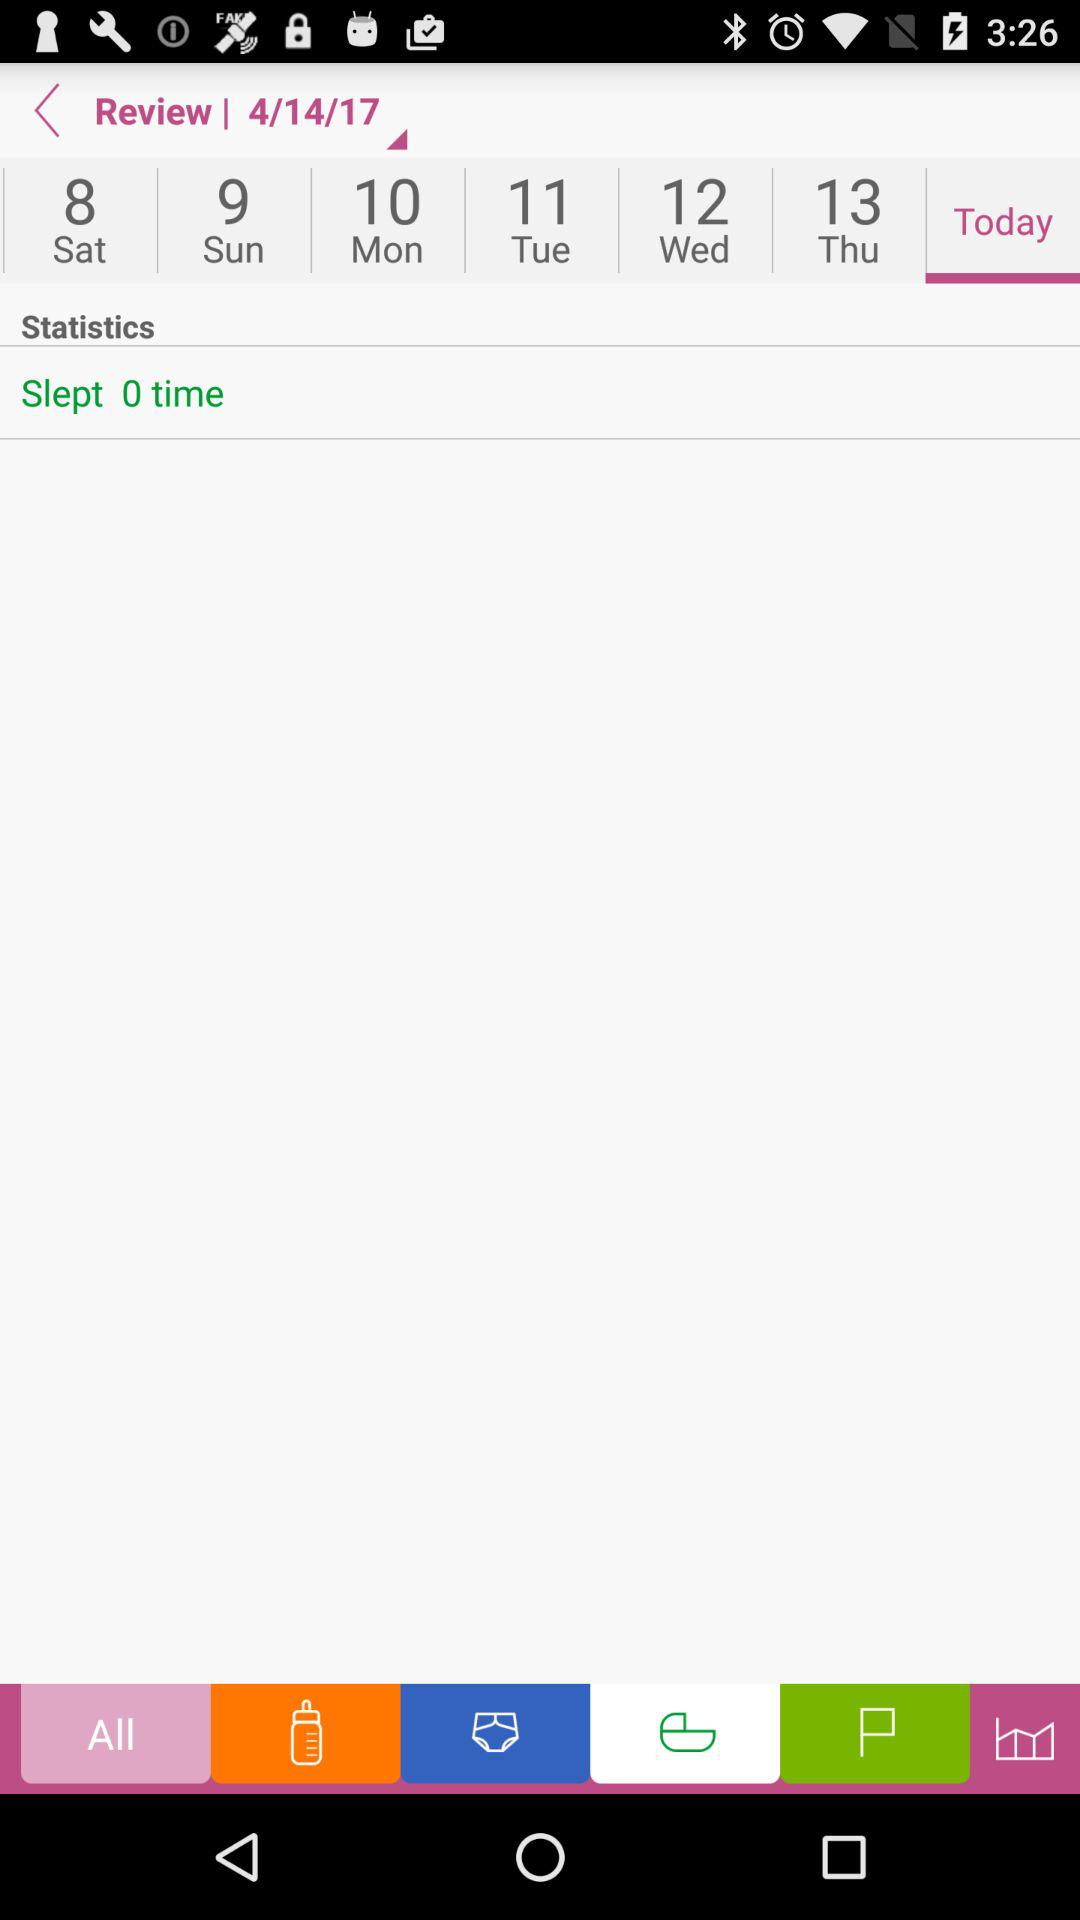What information is available in the statistics? The available information is "Slept 0 time". 